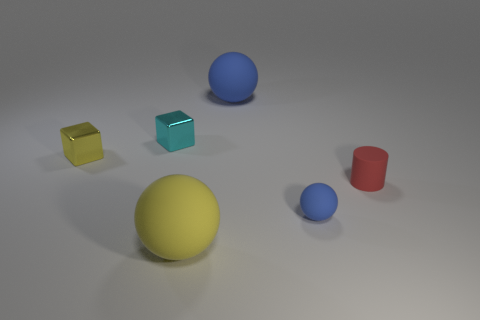Are there fewer big balls behind the tiny yellow shiny thing than tiny blue spheres?
Your answer should be compact. No. What shape is the yellow thing behind the large yellow rubber sphere?
Ensure brevity in your answer.  Cube. What is the shape of the cyan metal object that is the same size as the red thing?
Make the answer very short. Cube. Is there a purple shiny object that has the same shape as the cyan shiny thing?
Keep it short and to the point. No. There is a big matte thing in front of the tiny sphere; does it have the same shape as the blue matte object left of the tiny blue thing?
Offer a terse response. Yes. What material is the other sphere that is the same size as the yellow sphere?
Provide a short and direct response. Rubber. How many other things are there of the same material as the cyan block?
Your answer should be compact. 1. There is a large matte object on the left side of the big rubber thing that is behind the small matte ball; what is its shape?
Keep it short and to the point. Sphere. How many objects are either purple rubber cubes or objects on the right side of the small yellow block?
Your answer should be compact. 5. How many other things are the same color as the small ball?
Your response must be concise. 1. 